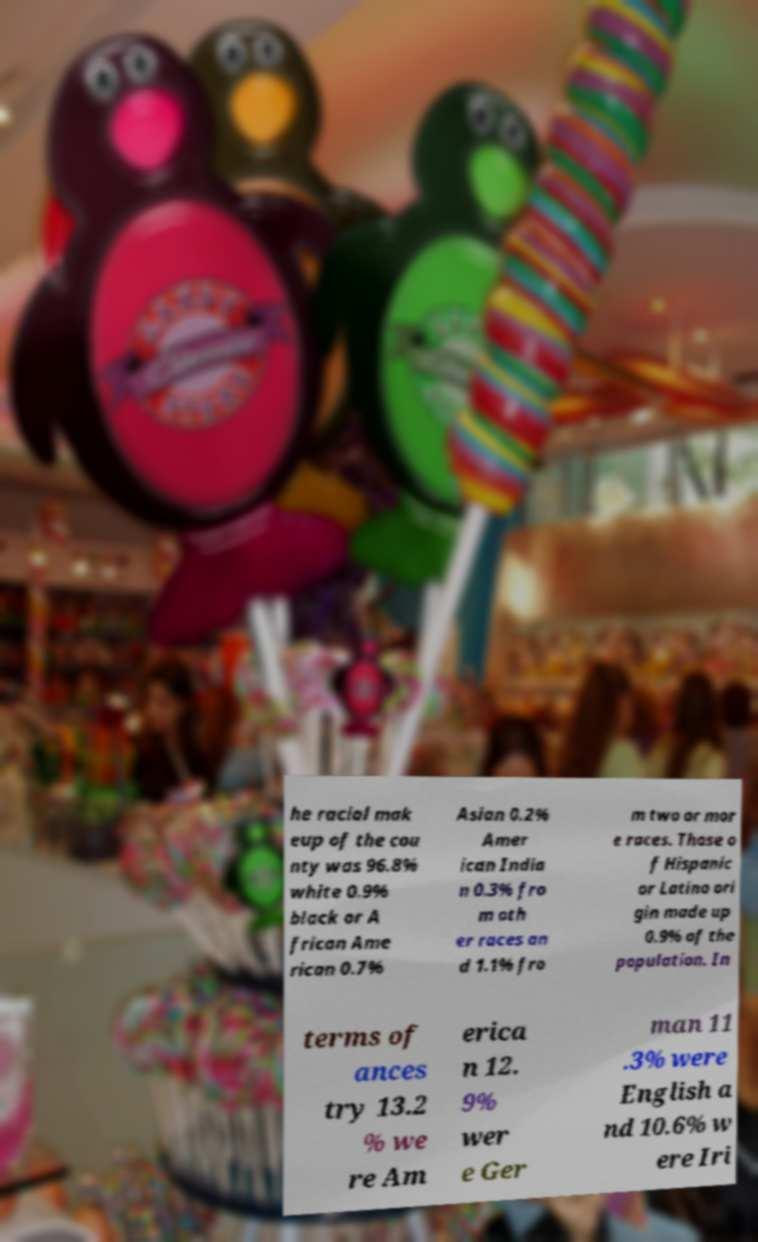Can you accurately transcribe the text from the provided image for me? he racial mak eup of the cou nty was 96.8% white 0.9% black or A frican Ame rican 0.7% Asian 0.2% Amer ican India n 0.3% fro m oth er races an d 1.1% fro m two or mor e races. Those o f Hispanic or Latino ori gin made up 0.9% of the population. In terms of ances try 13.2 % we re Am erica n 12. 9% wer e Ger man 11 .3% were English a nd 10.6% w ere Iri 